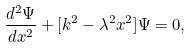<formula> <loc_0><loc_0><loc_500><loc_500>\frac { d ^ { 2 } \Psi } { d x ^ { 2 } } + [ k ^ { 2 } - \lambda ^ { 2 } x ^ { 2 } ] \Psi = 0 ,</formula> 